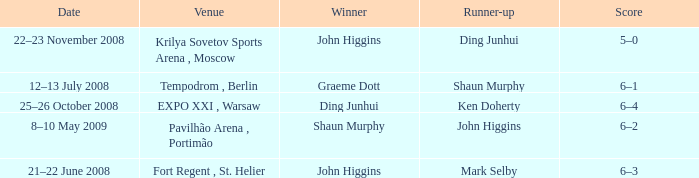When was the match that had Shaun Murphy as runner-up? 12–13 July 2008. 